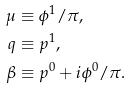Convert formula to latex. <formula><loc_0><loc_0><loc_500><loc_500>\mu & \equiv \phi ^ { 1 } / \pi , \\ q & \equiv p ^ { 1 } , \\ \beta & \equiv p ^ { 0 } + i \phi ^ { 0 } / \pi .</formula> 